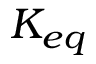Convert formula to latex. <formula><loc_0><loc_0><loc_500><loc_500>K _ { e q }</formula> 